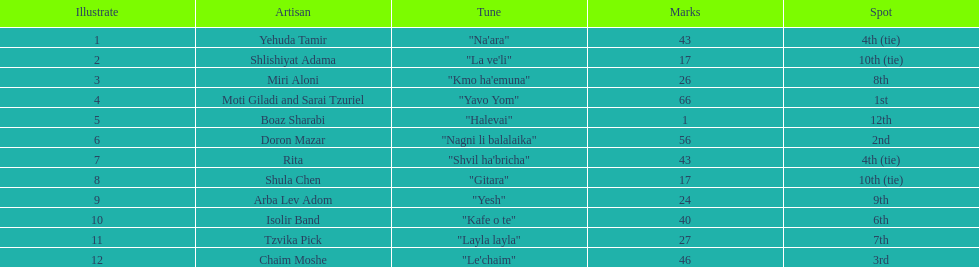Could you parse the entire table? {'header': ['Illustrate', 'Artisan', 'Tune', 'Marks', 'Spot'], 'rows': [['1', 'Yehuda Tamir', '"Na\'ara"', '43', '4th (tie)'], ['2', 'Shlishiyat Adama', '"La ve\'li"', '17', '10th (tie)'], ['3', 'Miri Aloni', '"Kmo ha\'emuna"', '26', '8th'], ['4', 'Moti Giladi and Sarai Tzuriel', '"Yavo Yom"', '66', '1st'], ['5', 'Boaz Sharabi', '"Halevai"', '1', '12th'], ['6', 'Doron Mazar', '"Nagni li balalaika"', '56', '2nd'], ['7', 'Rita', '"Shvil ha\'bricha"', '43', '4th (tie)'], ['8', 'Shula Chen', '"Gitara"', '17', '10th (tie)'], ['9', 'Arba Lev Adom', '"Yesh"', '24', '9th'], ['10', 'Isolir Band', '"Kafe o te"', '40', '6th'], ['11', 'Tzvika Pick', '"Layla layla"', '27', '7th'], ['12', 'Chaim Moshe', '"Le\'chaim"', '46', '3rd']]} How many points does the artist rita have? 43. 